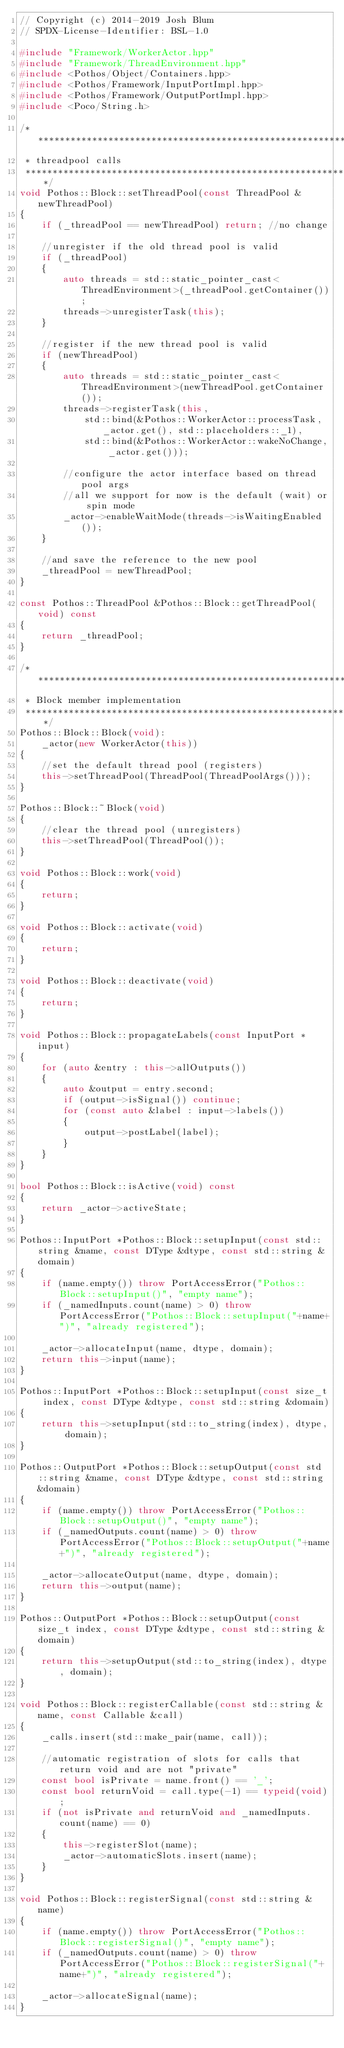<code> <loc_0><loc_0><loc_500><loc_500><_C++_>// Copyright (c) 2014-2019 Josh Blum
// SPDX-License-Identifier: BSL-1.0

#include "Framework/WorkerActor.hpp"
#include "Framework/ThreadEnvironment.hpp"
#include <Pothos/Object/Containers.hpp>
#include <Pothos/Framework/InputPortImpl.hpp>
#include <Pothos/Framework/OutputPortImpl.hpp>
#include <Poco/String.h>

/***********************************************************************
 * threadpool calls
 **********************************************************************/
void Pothos::Block::setThreadPool(const ThreadPool &newThreadPool)
{
    if (_threadPool == newThreadPool) return; //no change

    //unregister if the old thread pool is valid
    if (_threadPool)
    {
        auto threads = std::static_pointer_cast<ThreadEnvironment>(_threadPool.getContainer());
        threads->unregisterTask(this);
    }

    //register if the new thread pool is valid
    if (newThreadPool)
    {
        auto threads = std::static_pointer_cast<ThreadEnvironment>(newThreadPool.getContainer());
        threads->registerTask(this,
            std::bind(&Pothos::WorkerActor::processTask, _actor.get(), std::placeholders::_1),
            std::bind(&Pothos::WorkerActor::wakeNoChange, _actor.get()));

        //configure the actor interface based on thread pool args
        //all we support for now is the default (wait) or spin mode
        _actor->enableWaitMode(threads->isWaitingEnabled());
    }

    //and save the reference to the new pool
    _threadPool = newThreadPool;
}

const Pothos::ThreadPool &Pothos::Block::getThreadPool(void) const
{
    return _threadPool;
}

/***********************************************************************
 * Block member implementation
 **********************************************************************/
Pothos::Block::Block(void):
    _actor(new WorkerActor(this))
{
    //set the default thread pool (registers)
    this->setThreadPool(ThreadPool(ThreadPoolArgs()));
}

Pothos::Block::~Block(void)
{
    //clear the thread pool (unregisters)
    this->setThreadPool(ThreadPool());
}

void Pothos::Block::work(void)
{
    return;
}

void Pothos::Block::activate(void)
{
    return;
}

void Pothos::Block::deactivate(void)
{
    return;
}

void Pothos::Block::propagateLabels(const InputPort *input)
{
    for (auto &entry : this->allOutputs())
    {
        auto &output = entry.second;
        if (output->isSignal()) continue;
        for (const auto &label : input->labels())
        {
            output->postLabel(label);
        }
    }
}

bool Pothos::Block::isActive(void) const
{
    return _actor->activeState;
}

Pothos::InputPort *Pothos::Block::setupInput(const std::string &name, const DType &dtype, const std::string &domain)
{
    if (name.empty()) throw PortAccessError("Pothos::Block::setupInput()", "empty name");
    if (_namedInputs.count(name) > 0) throw PortAccessError("Pothos::Block::setupInput("+name+")", "already registered");

    _actor->allocateInput(name, dtype, domain);
    return this->input(name);
}

Pothos::InputPort *Pothos::Block::setupInput(const size_t index, const DType &dtype, const std::string &domain)
{
    return this->setupInput(std::to_string(index), dtype, domain);
}

Pothos::OutputPort *Pothos::Block::setupOutput(const std::string &name, const DType &dtype, const std::string &domain)
{
    if (name.empty()) throw PortAccessError("Pothos::Block::setupOutput()", "empty name");
    if (_namedOutputs.count(name) > 0) throw PortAccessError("Pothos::Block::setupOutput("+name+")", "already registered");

    _actor->allocateOutput(name, dtype, domain);
    return this->output(name);
}

Pothos::OutputPort *Pothos::Block::setupOutput(const size_t index, const DType &dtype, const std::string &domain)
{
    return this->setupOutput(std::to_string(index), dtype, domain);
}

void Pothos::Block::registerCallable(const std::string &name, const Callable &call)
{
    _calls.insert(std::make_pair(name, call));

    //automatic registration of slots for calls that return void and are not "private"
    const bool isPrivate = name.front() == '_';
    const bool returnVoid = call.type(-1) == typeid(void);
    if (not isPrivate and returnVoid and _namedInputs.count(name) == 0)
    {
        this->registerSlot(name);
        _actor->automaticSlots.insert(name);
    }
}

void Pothos::Block::registerSignal(const std::string &name)
{
    if (name.empty()) throw PortAccessError("Pothos::Block::registerSignal()", "empty name");
    if (_namedOutputs.count(name) > 0) throw PortAccessError("Pothos::Block::registerSignal("+name+")", "already registered");

    _actor->allocateSignal(name);
}
</code> 